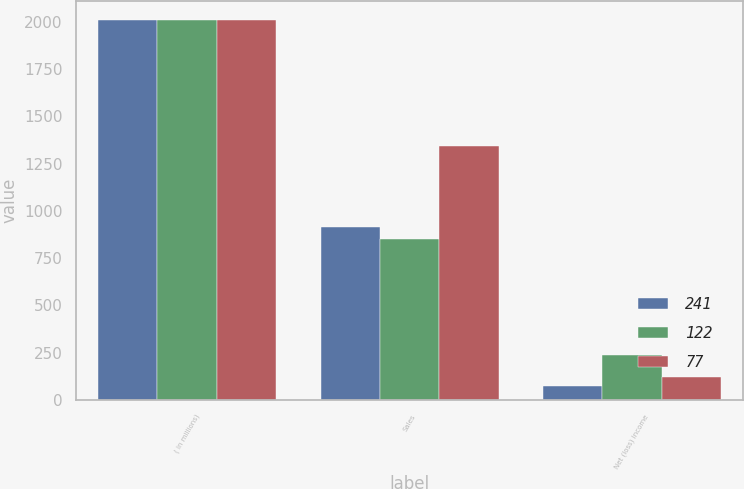Convert chart. <chart><loc_0><loc_0><loc_500><loc_500><stacked_bar_chart><ecel><fcel>( in millions)<fcel>Sales<fcel>Net (loss) income<nl><fcel>241<fcel>2010<fcel>914<fcel>77<nl><fcel>122<fcel>2009<fcel>850<fcel>241<nl><fcel>77<fcel>2008<fcel>1342<fcel>122<nl></chart> 